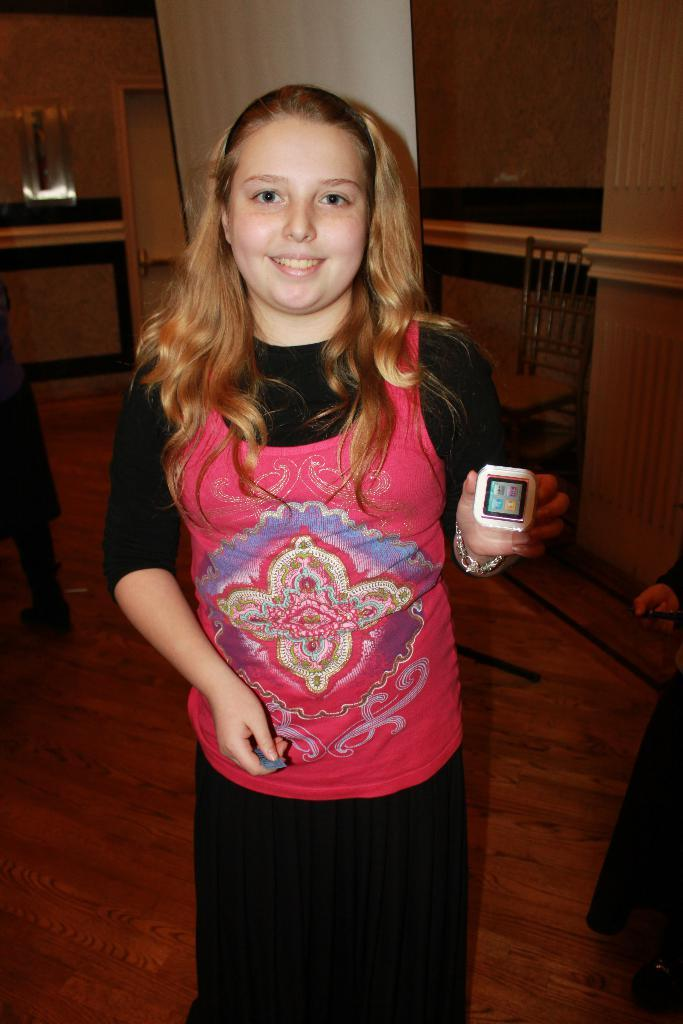What is the main subject of the image? The main subject of the image is a small girl. What is the girl holding in her hand? The girl is holding an electronic device in one of her hands. What type of badge is the girl wearing in the image? There is no badge visible in the image. What smell can be detected in the image? There is no mention of any smell in the image. 